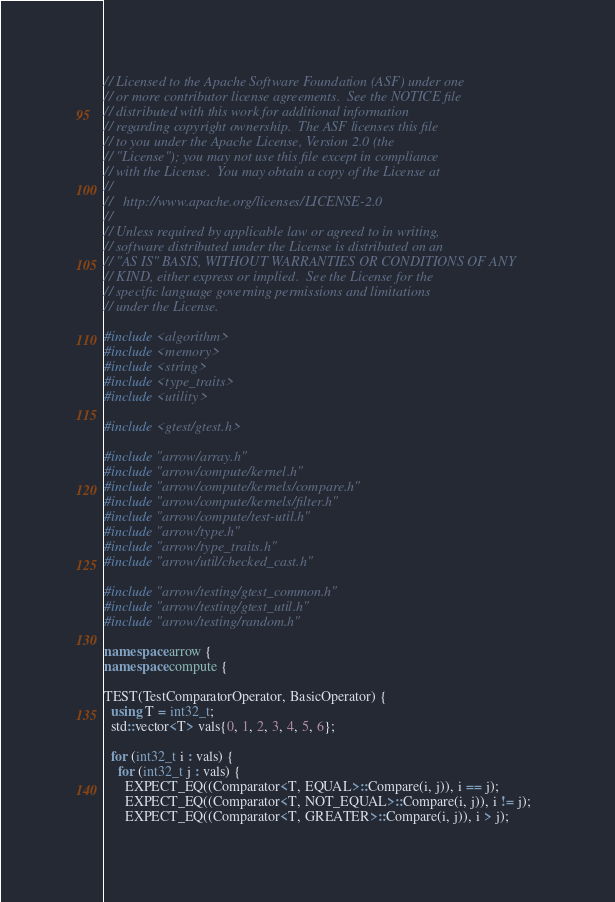Convert code to text. <code><loc_0><loc_0><loc_500><loc_500><_C++_>// Licensed to the Apache Software Foundation (ASF) under one
// or more contributor license agreements.  See the NOTICE file
// distributed with this work for additional information
// regarding copyright ownership.  The ASF licenses this file
// to you under the Apache License, Version 2.0 (the
// "License"); you may not use this file except in compliance
// with the License.  You may obtain a copy of the License at
//
//   http://www.apache.org/licenses/LICENSE-2.0
//
// Unless required by applicable law or agreed to in writing,
// software distributed under the License is distributed on an
// "AS IS" BASIS, WITHOUT WARRANTIES OR CONDITIONS OF ANY
// KIND, either express or implied.  See the License for the
// specific language governing permissions and limitations
// under the License.

#include <algorithm>
#include <memory>
#include <string>
#include <type_traits>
#include <utility>

#include <gtest/gtest.h>

#include "arrow/array.h"
#include "arrow/compute/kernel.h"
#include "arrow/compute/kernels/compare.h"
#include "arrow/compute/kernels/filter.h"
#include "arrow/compute/test-util.h"
#include "arrow/type.h"
#include "arrow/type_traits.h"
#include "arrow/util/checked_cast.h"

#include "arrow/testing/gtest_common.h"
#include "arrow/testing/gtest_util.h"
#include "arrow/testing/random.h"

namespace arrow {
namespace compute {

TEST(TestComparatorOperator, BasicOperator) {
  using T = int32_t;
  std::vector<T> vals{0, 1, 2, 3, 4, 5, 6};

  for (int32_t i : vals) {
    for (int32_t j : vals) {
      EXPECT_EQ((Comparator<T, EQUAL>::Compare(i, j)), i == j);
      EXPECT_EQ((Comparator<T, NOT_EQUAL>::Compare(i, j)), i != j);
      EXPECT_EQ((Comparator<T, GREATER>::Compare(i, j)), i > j);</code> 